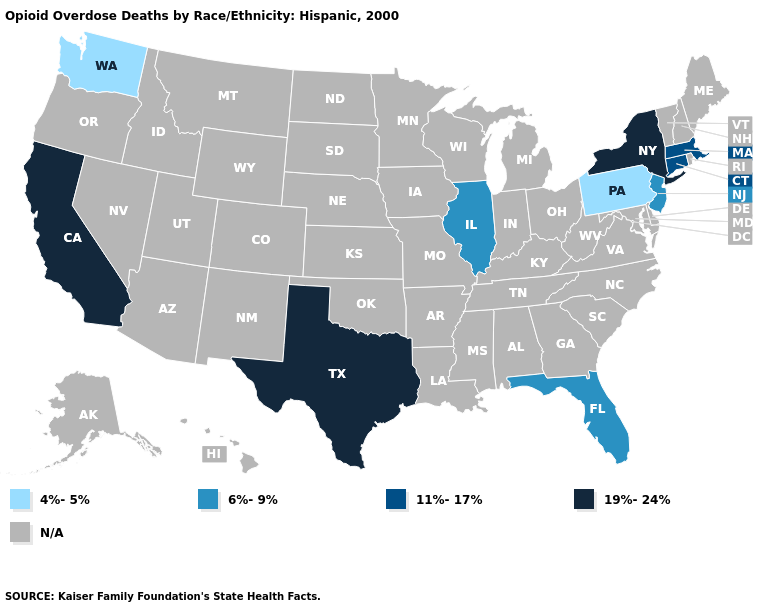Is the legend a continuous bar?
Keep it brief. No. Does Pennsylvania have the highest value in the Northeast?
Keep it brief. No. Which states have the highest value in the USA?
Quick response, please. California, New York, Texas. Name the states that have a value in the range 6%-9%?
Keep it brief. Florida, Illinois, New Jersey. What is the lowest value in the West?
Write a very short answer. 4%-5%. Is the legend a continuous bar?
Give a very brief answer. No. Is the legend a continuous bar?
Write a very short answer. No. Does the first symbol in the legend represent the smallest category?
Write a very short answer. Yes. Among the states that border Delaware , which have the highest value?
Give a very brief answer. New Jersey. Does the first symbol in the legend represent the smallest category?
Concise answer only. Yes. What is the lowest value in states that border New Mexico?
Give a very brief answer. 19%-24%. 